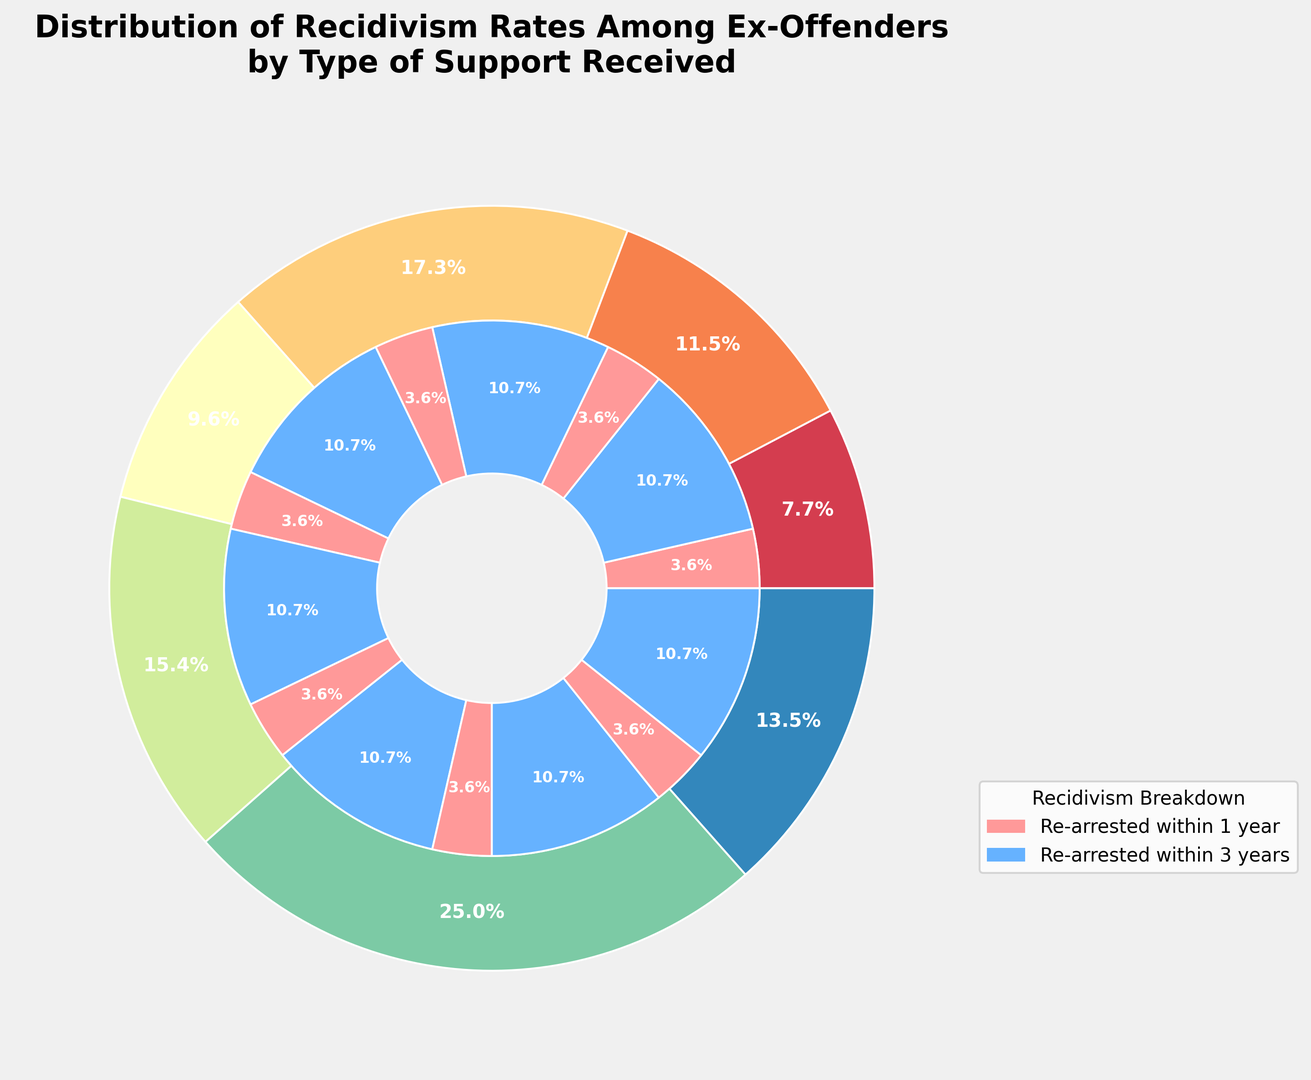What type of support has the highest recidivism rate? The outer pie shows the recidivism rates among different support types. The largest portion of the outer pie represents "No Support" with a rate of 65%.
Answer: No Support Which type of support has the lowest recidivism rate? The outer pie chart indicates that "Comprehensive Support" has the smallest portion of the pie, with a recidivism rate of 20%.
Answer: Comprehensive Support What is the total percentage of ex-offenders re-arrested within 1 year across all support types? Sum up the inner pie segments representing re-arrested within 1 year for each support type: 40 + 25 + 20 + 15 + 10 + 10 + 5 = 125%.
Answer: 125% Compare the recidivism rates of ex-offenders who received Employment Assistance and those who received Education Programs. Which is higher? "Employment Assistance" has a recidivism rate of 45%, while "Education Programs" has a recidivism rate of 30%. Therefore, Employment Assistance has a higher recidivism rate.
Answer: Employment Assistance Among ex-offenders who received Mental Health Services, what percentage was re-arrested within 3 years? The inner pie chart segment for Mental Health Services shows re-arrested within 3 years at 20%.
Answer: 20% Among ex-offenders who received Substance Abuse Treatment, what is the difference in the percentages re-arrested within 1 year versus 3 years? For Substance Abuse Treatment, re-arrested within 1 year is 15%, and re-arrested within 3 years is 20%. The difference is 20% - 15% = 5%.
Answer: 5% Is the percentage of ex-offenders re-arrested within 3 years for those who received Housing Assistance more or less than their re-arrest rate within 1 year? For Housing Assistance, the inner pie shows 10% re-arrested within 1 year and 15% re-arrested within 3 years, so the 3 years rate is higher.
Answer: More What support type has an equal percentage of ex-offenders re-arrested within 1 year and within 3 years? The inner pie for "Mental Health Services" shows equal segments for re-arrested within 1 year and 3 years, both at 20%.
Answer: Mental Health Services What is the combined recidivism rate for ex-offenders re-arrested within 3 years who received both No Support and Employment Assistance? For No Support, re-arrested within 3 years is 25%, and for Employment Assistance, it is 20%. The combined rate is 25% + 20% = 45%.
Answer: 45% 